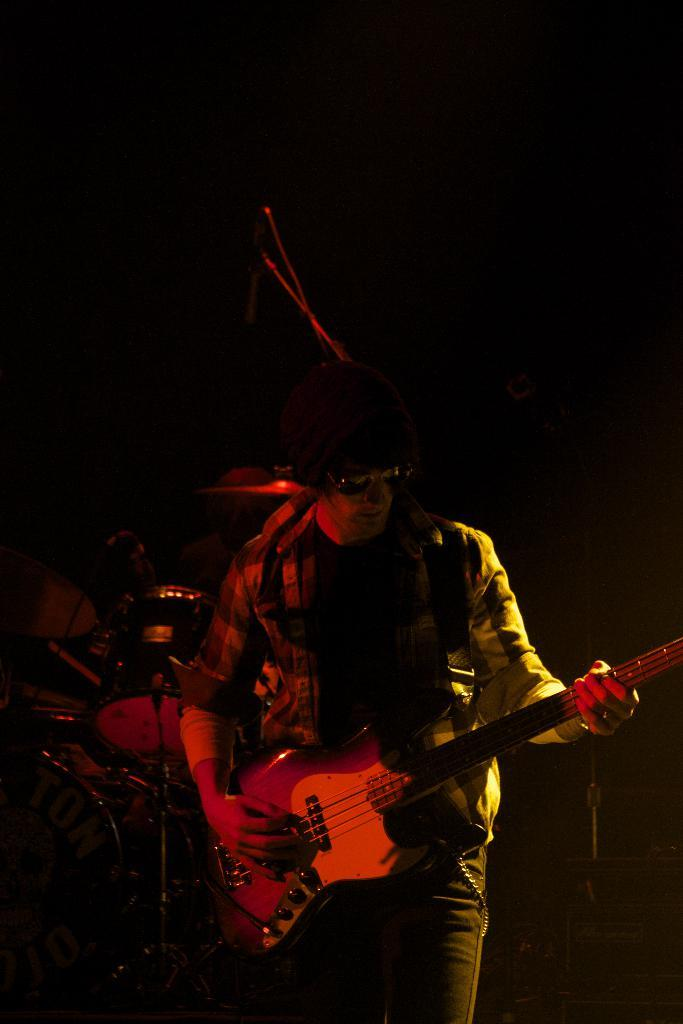Who is the main subject in the image? There is a man in the image. What is the man wearing on his face? The man is wearing goggles. What is the man holding in the image? The man is holding a guitar. What is the man doing with the guitar? The man is playing the guitar. What other musical instruments can be seen in the image? There are musical instruments in the background. What device is present in the background for amplifying sound? There is a microphone in the background. Can you see the man's tail wagging in the image? There is no tail present in the image, as the subject is a man. What type of glove is the man wearing while playing the guitar? The man is not wearing any gloves in the image; he is only wearing goggles. 